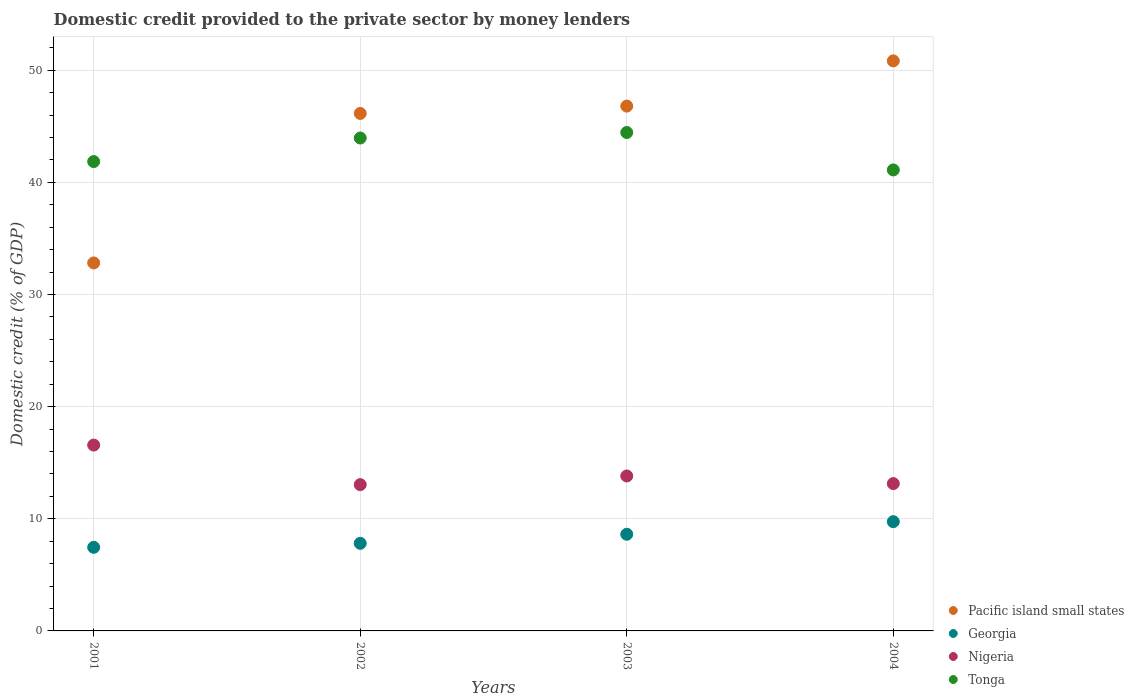What is the domestic credit provided to the private sector by money lenders in Nigeria in 2002?
Provide a succinct answer. 13.04. Across all years, what is the maximum domestic credit provided to the private sector by money lenders in Nigeria?
Offer a very short reply. 16.57. Across all years, what is the minimum domestic credit provided to the private sector by money lenders in Nigeria?
Ensure brevity in your answer.  13.04. In which year was the domestic credit provided to the private sector by money lenders in Tonga maximum?
Your answer should be very brief. 2003. In which year was the domestic credit provided to the private sector by money lenders in Georgia minimum?
Keep it short and to the point. 2001. What is the total domestic credit provided to the private sector by money lenders in Pacific island small states in the graph?
Ensure brevity in your answer.  176.58. What is the difference between the domestic credit provided to the private sector by money lenders in Nigeria in 2001 and that in 2002?
Your response must be concise. 3.53. What is the difference between the domestic credit provided to the private sector by money lenders in Tonga in 2002 and the domestic credit provided to the private sector by money lenders in Pacific island small states in 2003?
Offer a very short reply. -2.84. What is the average domestic credit provided to the private sector by money lenders in Georgia per year?
Offer a very short reply. 8.41. In the year 2004, what is the difference between the domestic credit provided to the private sector by money lenders in Nigeria and domestic credit provided to the private sector by money lenders in Tonga?
Your response must be concise. -27.97. In how many years, is the domestic credit provided to the private sector by money lenders in Tonga greater than 38 %?
Ensure brevity in your answer.  4. What is the ratio of the domestic credit provided to the private sector by money lenders in Pacific island small states in 2002 to that in 2004?
Ensure brevity in your answer.  0.91. Is the domestic credit provided to the private sector by money lenders in Pacific island small states in 2001 less than that in 2003?
Your answer should be compact. Yes. What is the difference between the highest and the second highest domestic credit provided to the private sector by money lenders in Georgia?
Give a very brief answer. 1.12. What is the difference between the highest and the lowest domestic credit provided to the private sector by money lenders in Tonga?
Your response must be concise. 3.34. In how many years, is the domestic credit provided to the private sector by money lenders in Pacific island small states greater than the average domestic credit provided to the private sector by money lenders in Pacific island small states taken over all years?
Offer a terse response. 3. Is the sum of the domestic credit provided to the private sector by money lenders in Pacific island small states in 2001 and 2004 greater than the maximum domestic credit provided to the private sector by money lenders in Nigeria across all years?
Ensure brevity in your answer.  Yes. Is it the case that in every year, the sum of the domestic credit provided to the private sector by money lenders in Nigeria and domestic credit provided to the private sector by money lenders in Tonga  is greater than the domestic credit provided to the private sector by money lenders in Pacific island small states?
Offer a very short reply. Yes. Does the domestic credit provided to the private sector by money lenders in Nigeria monotonically increase over the years?
Ensure brevity in your answer.  No. What is the difference between two consecutive major ticks on the Y-axis?
Your answer should be very brief. 10. Does the graph contain grids?
Your answer should be compact. Yes. How many legend labels are there?
Your response must be concise. 4. How are the legend labels stacked?
Your answer should be very brief. Vertical. What is the title of the graph?
Ensure brevity in your answer.  Domestic credit provided to the private sector by money lenders. Does "Venezuela" appear as one of the legend labels in the graph?
Offer a very short reply. No. What is the label or title of the X-axis?
Your answer should be very brief. Years. What is the label or title of the Y-axis?
Offer a terse response. Domestic credit (% of GDP). What is the Domestic credit (% of GDP) of Pacific island small states in 2001?
Give a very brief answer. 32.81. What is the Domestic credit (% of GDP) of Georgia in 2001?
Your answer should be compact. 7.45. What is the Domestic credit (% of GDP) of Nigeria in 2001?
Provide a succinct answer. 16.57. What is the Domestic credit (% of GDP) in Tonga in 2001?
Offer a very short reply. 41.85. What is the Domestic credit (% of GDP) of Pacific island small states in 2002?
Your response must be concise. 46.14. What is the Domestic credit (% of GDP) of Georgia in 2002?
Offer a very short reply. 7.81. What is the Domestic credit (% of GDP) in Nigeria in 2002?
Provide a succinct answer. 13.04. What is the Domestic credit (% of GDP) of Tonga in 2002?
Provide a succinct answer. 43.95. What is the Domestic credit (% of GDP) of Pacific island small states in 2003?
Offer a terse response. 46.8. What is the Domestic credit (% of GDP) of Georgia in 2003?
Your response must be concise. 8.62. What is the Domestic credit (% of GDP) in Nigeria in 2003?
Make the answer very short. 13.82. What is the Domestic credit (% of GDP) of Tonga in 2003?
Your answer should be compact. 44.44. What is the Domestic credit (% of GDP) of Pacific island small states in 2004?
Make the answer very short. 50.83. What is the Domestic credit (% of GDP) in Georgia in 2004?
Keep it short and to the point. 9.74. What is the Domestic credit (% of GDP) of Nigeria in 2004?
Offer a terse response. 13.14. What is the Domestic credit (% of GDP) in Tonga in 2004?
Your answer should be very brief. 41.11. Across all years, what is the maximum Domestic credit (% of GDP) in Pacific island small states?
Your response must be concise. 50.83. Across all years, what is the maximum Domestic credit (% of GDP) in Georgia?
Offer a terse response. 9.74. Across all years, what is the maximum Domestic credit (% of GDP) of Nigeria?
Ensure brevity in your answer.  16.57. Across all years, what is the maximum Domestic credit (% of GDP) of Tonga?
Keep it short and to the point. 44.44. Across all years, what is the minimum Domestic credit (% of GDP) in Pacific island small states?
Make the answer very short. 32.81. Across all years, what is the minimum Domestic credit (% of GDP) in Georgia?
Keep it short and to the point. 7.45. Across all years, what is the minimum Domestic credit (% of GDP) of Nigeria?
Your response must be concise. 13.04. Across all years, what is the minimum Domestic credit (% of GDP) in Tonga?
Your answer should be very brief. 41.11. What is the total Domestic credit (% of GDP) in Pacific island small states in the graph?
Offer a terse response. 176.58. What is the total Domestic credit (% of GDP) of Georgia in the graph?
Your answer should be very brief. 33.63. What is the total Domestic credit (% of GDP) of Nigeria in the graph?
Give a very brief answer. 56.57. What is the total Domestic credit (% of GDP) in Tonga in the graph?
Your answer should be compact. 171.35. What is the difference between the Domestic credit (% of GDP) in Pacific island small states in 2001 and that in 2002?
Keep it short and to the point. -13.33. What is the difference between the Domestic credit (% of GDP) of Georgia in 2001 and that in 2002?
Offer a terse response. -0.36. What is the difference between the Domestic credit (% of GDP) of Nigeria in 2001 and that in 2002?
Your response must be concise. 3.53. What is the difference between the Domestic credit (% of GDP) in Tonga in 2001 and that in 2002?
Ensure brevity in your answer.  -2.1. What is the difference between the Domestic credit (% of GDP) in Pacific island small states in 2001 and that in 2003?
Offer a very short reply. -13.98. What is the difference between the Domestic credit (% of GDP) in Georgia in 2001 and that in 2003?
Offer a terse response. -1.16. What is the difference between the Domestic credit (% of GDP) in Nigeria in 2001 and that in 2003?
Your answer should be very brief. 2.76. What is the difference between the Domestic credit (% of GDP) in Tonga in 2001 and that in 2003?
Your answer should be compact. -2.59. What is the difference between the Domestic credit (% of GDP) in Pacific island small states in 2001 and that in 2004?
Ensure brevity in your answer.  -18.01. What is the difference between the Domestic credit (% of GDP) in Georgia in 2001 and that in 2004?
Keep it short and to the point. -2.29. What is the difference between the Domestic credit (% of GDP) in Nigeria in 2001 and that in 2004?
Offer a terse response. 3.44. What is the difference between the Domestic credit (% of GDP) of Tonga in 2001 and that in 2004?
Ensure brevity in your answer.  0.74. What is the difference between the Domestic credit (% of GDP) in Pacific island small states in 2002 and that in 2003?
Offer a very short reply. -0.65. What is the difference between the Domestic credit (% of GDP) in Georgia in 2002 and that in 2003?
Your answer should be very brief. -0.81. What is the difference between the Domestic credit (% of GDP) in Nigeria in 2002 and that in 2003?
Provide a succinct answer. -0.77. What is the difference between the Domestic credit (% of GDP) in Tonga in 2002 and that in 2003?
Your answer should be compact. -0.49. What is the difference between the Domestic credit (% of GDP) of Pacific island small states in 2002 and that in 2004?
Your answer should be compact. -4.69. What is the difference between the Domestic credit (% of GDP) of Georgia in 2002 and that in 2004?
Your answer should be compact. -1.93. What is the difference between the Domestic credit (% of GDP) in Nigeria in 2002 and that in 2004?
Provide a short and direct response. -0.09. What is the difference between the Domestic credit (% of GDP) of Tonga in 2002 and that in 2004?
Offer a very short reply. 2.85. What is the difference between the Domestic credit (% of GDP) of Pacific island small states in 2003 and that in 2004?
Ensure brevity in your answer.  -4.03. What is the difference between the Domestic credit (% of GDP) of Georgia in 2003 and that in 2004?
Give a very brief answer. -1.12. What is the difference between the Domestic credit (% of GDP) of Nigeria in 2003 and that in 2004?
Keep it short and to the point. 0.68. What is the difference between the Domestic credit (% of GDP) of Tonga in 2003 and that in 2004?
Keep it short and to the point. 3.34. What is the difference between the Domestic credit (% of GDP) in Pacific island small states in 2001 and the Domestic credit (% of GDP) in Georgia in 2002?
Make the answer very short. 25. What is the difference between the Domestic credit (% of GDP) of Pacific island small states in 2001 and the Domestic credit (% of GDP) of Nigeria in 2002?
Offer a terse response. 19.77. What is the difference between the Domestic credit (% of GDP) of Pacific island small states in 2001 and the Domestic credit (% of GDP) of Tonga in 2002?
Offer a terse response. -11.14. What is the difference between the Domestic credit (% of GDP) of Georgia in 2001 and the Domestic credit (% of GDP) of Nigeria in 2002?
Offer a very short reply. -5.59. What is the difference between the Domestic credit (% of GDP) of Georgia in 2001 and the Domestic credit (% of GDP) of Tonga in 2002?
Your answer should be compact. -36.5. What is the difference between the Domestic credit (% of GDP) of Nigeria in 2001 and the Domestic credit (% of GDP) of Tonga in 2002?
Make the answer very short. -27.38. What is the difference between the Domestic credit (% of GDP) in Pacific island small states in 2001 and the Domestic credit (% of GDP) in Georgia in 2003?
Offer a terse response. 24.19. What is the difference between the Domestic credit (% of GDP) of Pacific island small states in 2001 and the Domestic credit (% of GDP) of Nigeria in 2003?
Your answer should be compact. 19. What is the difference between the Domestic credit (% of GDP) in Pacific island small states in 2001 and the Domestic credit (% of GDP) in Tonga in 2003?
Your answer should be very brief. -11.63. What is the difference between the Domestic credit (% of GDP) in Georgia in 2001 and the Domestic credit (% of GDP) in Nigeria in 2003?
Offer a terse response. -6.36. What is the difference between the Domestic credit (% of GDP) in Georgia in 2001 and the Domestic credit (% of GDP) in Tonga in 2003?
Provide a succinct answer. -36.99. What is the difference between the Domestic credit (% of GDP) in Nigeria in 2001 and the Domestic credit (% of GDP) in Tonga in 2003?
Your response must be concise. -27.87. What is the difference between the Domestic credit (% of GDP) in Pacific island small states in 2001 and the Domestic credit (% of GDP) in Georgia in 2004?
Provide a short and direct response. 23.07. What is the difference between the Domestic credit (% of GDP) of Pacific island small states in 2001 and the Domestic credit (% of GDP) of Nigeria in 2004?
Ensure brevity in your answer.  19.68. What is the difference between the Domestic credit (% of GDP) in Pacific island small states in 2001 and the Domestic credit (% of GDP) in Tonga in 2004?
Give a very brief answer. -8.29. What is the difference between the Domestic credit (% of GDP) of Georgia in 2001 and the Domestic credit (% of GDP) of Nigeria in 2004?
Give a very brief answer. -5.68. What is the difference between the Domestic credit (% of GDP) in Georgia in 2001 and the Domestic credit (% of GDP) in Tonga in 2004?
Provide a short and direct response. -33.65. What is the difference between the Domestic credit (% of GDP) of Nigeria in 2001 and the Domestic credit (% of GDP) of Tonga in 2004?
Offer a very short reply. -24.53. What is the difference between the Domestic credit (% of GDP) of Pacific island small states in 2002 and the Domestic credit (% of GDP) of Georgia in 2003?
Ensure brevity in your answer.  37.52. What is the difference between the Domestic credit (% of GDP) of Pacific island small states in 2002 and the Domestic credit (% of GDP) of Nigeria in 2003?
Your response must be concise. 32.33. What is the difference between the Domestic credit (% of GDP) in Pacific island small states in 2002 and the Domestic credit (% of GDP) in Tonga in 2003?
Provide a succinct answer. 1.7. What is the difference between the Domestic credit (% of GDP) of Georgia in 2002 and the Domestic credit (% of GDP) of Nigeria in 2003?
Give a very brief answer. -6.01. What is the difference between the Domestic credit (% of GDP) of Georgia in 2002 and the Domestic credit (% of GDP) of Tonga in 2003?
Offer a very short reply. -36.63. What is the difference between the Domestic credit (% of GDP) in Nigeria in 2002 and the Domestic credit (% of GDP) in Tonga in 2003?
Keep it short and to the point. -31.4. What is the difference between the Domestic credit (% of GDP) of Pacific island small states in 2002 and the Domestic credit (% of GDP) of Georgia in 2004?
Give a very brief answer. 36.4. What is the difference between the Domestic credit (% of GDP) of Pacific island small states in 2002 and the Domestic credit (% of GDP) of Nigeria in 2004?
Keep it short and to the point. 33.01. What is the difference between the Domestic credit (% of GDP) in Pacific island small states in 2002 and the Domestic credit (% of GDP) in Tonga in 2004?
Your answer should be compact. 5.04. What is the difference between the Domestic credit (% of GDP) of Georgia in 2002 and the Domestic credit (% of GDP) of Nigeria in 2004?
Make the answer very short. -5.33. What is the difference between the Domestic credit (% of GDP) of Georgia in 2002 and the Domestic credit (% of GDP) of Tonga in 2004?
Ensure brevity in your answer.  -33.3. What is the difference between the Domestic credit (% of GDP) in Nigeria in 2002 and the Domestic credit (% of GDP) in Tonga in 2004?
Offer a very short reply. -28.06. What is the difference between the Domestic credit (% of GDP) in Pacific island small states in 2003 and the Domestic credit (% of GDP) in Georgia in 2004?
Your response must be concise. 37.05. What is the difference between the Domestic credit (% of GDP) of Pacific island small states in 2003 and the Domestic credit (% of GDP) of Nigeria in 2004?
Provide a short and direct response. 33.66. What is the difference between the Domestic credit (% of GDP) in Pacific island small states in 2003 and the Domestic credit (% of GDP) in Tonga in 2004?
Offer a very short reply. 5.69. What is the difference between the Domestic credit (% of GDP) of Georgia in 2003 and the Domestic credit (% of GDP) of Nigeria in 2004?
Your response must be concise. -4.52. What is the difference between the Domestic credit (% of GDP) in Georgia in 2003 and the Domestic credit (% of GDP) in Tonga in 2004?
Make the answer very short. -32.49. What is the difference between the Domestic credit (% of GDP) of Nigeria in 2003 and the Domestic credit (% of GDP) of Tonga in 2004?
Your answer should be compact. -27.29. What is the average Domestic credit (% of GDP) in Pacific island small states per year?
Provide a short and direct response. 44.15. What is the average Domestic credit (% of GDP) in Georgia per year?
Ensure brevity in your answer.  8.41. What is the average Domestic credit (% of GDP) in Nigeria per year?
Keep it short and to the point. 14.14. What is the average Domestic credit (% of GDP) of Tonga per year?
Your answer should be very brief. 42.84. In the year 2001, what is the difference between the Domestic credit (% of GDP) in Pacific island small states and Domestic credit (% of GDP) in Georgia?
Offer a very short reply. 25.36. In the year 2001, what is the difference between the Domestic credit (% of GDP) in Pacific island small states and Domestic credit (% of GDP) in Nigeria?
Offer a terse response. 16.24. In the year 2001, what is the difference between the Domestic credit (% of GDP) of Pacific island small states and Domestic credit (% of GDP) of Tonga?
Provide a short and direct response. -9.04. In the year 2001, what is the difference between the Domestic credit (% of GDP) in Georgia and Domestic credit (% of GDP) in Nigeria?
Your answer should be very brief. -9.12. In the year 2001, what is the difference between the Domestic credit (% of GDP) in Georgia and Domestic credit (% of GDP) in Tonga?
Offer a terse response. -34.4. In the year 2001, what is the difference between the Domestic credit (% of GDP) of Nigeria and Domestic credit (% of GDP) of Tonga?
Your answer should be compact. -25.28. In the year 2002, what is the difference between the Domestic credit (% of GDP) of Pacific island small states and Domestic credit (% of GDP) of Georgia?
Your answer should be very brief. 38.33. In the year 2002, what is the difference between the Domestic credit (% of GDP) in Pacific island small states and Domestic credit (% of GDP) in Nigeria?
Offer a terse response. 33.1. In the year 2002, what is the difference between the Domestic credit (% of GDP) of Pacific island small states and Domestic credit (% of GDP) of Tonga?
Offer a terse response. 2.19. In the year 2002, what is the difference between the Domestic credit (% of GDP) of Georgia and Domestic credit (% of GDP) of Nigeria?
Your response must be concise. -5.23. In the year 2002, what is the difference between the Domestic credit (% of GDP) in Georgia and Domestic credit (% of GDP) in Tonga?
Offer a terse response. -36.14. In the year 2002, what is the difference between the Domestic credit (% of GDP) in Nigeria and Domestic credit (% of GDP) in Tonga?
Make the answer very short. -30.91. In the year 2003, what is the difference between the Domestic credit (% of GDP) in Pacific island small states and Domestic credit (% of GDP) in Georgia?
Keep it short and to the point. 38.18. In the year 2003, what is the difference between the Domestic credit (% of GDP) of Pacific island small states and Domestic credit (% of GDP) of Nigeria?
Offer a very short reply. 32.98. In the year 2003, what is the difference between the Domestic credit (% of GDP) of Pacific island small states and Domestic credit (% of GDP) of Tonga?
Keep it short and to the point. 2.35. In the year 2003, what is the difference between the Domestic credit (% of GDP) in Georgia and Domestic credit (% of GDP) in Nigeria?
Give a very brief answer. -5.2. In the year 2003, what is the difference between the Domestic credit (% of GDP) in Georgia and Domestic credit (% of GDP) in Tonga?
Keep it short and to the point. -35.82. In the year 2003, what is the difference between the Domestic credit (% of GDP) in Nigeria and Domestic credit (% of GDP) in Tonga?
Your answer should be very brief. -30.63. In the year 2004, what is the difference between the Domestic credit (% of GDP) in Pacific island small states and Domestic credit (% of GDP) in Georgia?
Offer a terse response. 41.09. In the year 2004, what is the difference between the Domestic credit (% of GDP) of Pacific island small states and Domestic credit (% of GDP) of Nigeria?
Your response must be concise. 37.69. In the year 2004, what is the difference between the Domestic credit (% of GDP) of Pacific island small states and Domestic credit (% of GDP) of Tonga?
Make the answer very short. 9.72. In the year 2004, what is the difference between the Domestic credit (% of GDP) in Georgia and Domestic credit (% of GDP) in Nigeria?
Give a very brief answer. -3.4. In the year 2004, what is the difference between the Domestic credit (% of GDP) in Georgia and Domestic credit (% of GDP) in Tonga?
Your answer should be very brief. -31.36. In the year 2004, what is the difference between the Domestic credit (% of GDP) of Nigeria and Domestic credit (% of GDP) of Tonga?
Keep it short and to the point. -27.97. What is the ratio of the Domestic credit (% of GDP) of Pacific island small states in 2001 to that in 2002?
Offer a terse response. 0.71. What is the ratio of the Domestic credit (% of GDP) of Georgia in 2001 to that in 2002?
Your answer should be compact. 0.95. What is the ratio of the Domestic credit (% of GDP) in Nigeria in 2001 to that in 2002?
Offer a very short reply. 1.27. What is the ratio of the Domestic credit (% of GDP) of Tonga in 2001 to that in 2002?
Provide a short and direct response. 0.95. What is the ratio of the Domestic credit (% of GDP) in Pacific island small states in 2001 to that in 2003?
Keep it short and to the point. 0.7. What is the ratio of the Domestic credit (% of GDP) of Georgia in 2001 to that in 2003?
Provide a short and direct response. 0.86. What is the ratio of the Domestic credit (% of GDP) in Nigeria in 2001 to that in 2003?
Your response must be concise. 1.2. What is the ratio of the Domestic credit (% of GDP) of Tonga in 2001 to that in 2003?
Provide a short and direct response. 0.94. What is the ratio of the Domestic credit (% of GDP) of Pacific island small states in 2001 to that in 2004?
Make the answer very short. 0.65. What is the ratio of the Domestic credit (% of GDP) in Georgia in 2001 to that in 2004?
Make the answer very short. 0.77. What is the ratio of the Domestic credit (% of GDP) of Nigeria in 2001 to that in 2004?
Provide a short and direct response. 1.26. What is the ratio of the Domestic credit (% of GDP) of Tonga in 2001 to that in 2004?
Keep it short and to the point. 1.02. What is the ratio of the Domestic credit (% of GDP) of Georgia in 2002 to that in 2003?
Offer a very short reply. 0.91. What is the ratio of the Domestic credit (% of GDP) in Nigeria in 2002 to that in 2003?
Offer a very short reply. 0.94. What is the ratio of the Domestic credit (% of GDP) of Pacific island small states in 2002 to that in 2004?
Your answer should be compact. 0.91. What is the ratio of the Domestic credit (% of GDP) of Georgia in 2002 to that in 2004?
Keep it short and to the point. 0.8. What is the ratio of the Domestic credit (% of GDP) of Nigeria in 2002 to that in 2004?
Provide a short and direct response. 0.99. What is the ratio of the Domestic credit (% of GDP) in Tonga in 2002 to that in 2004?
Ensure brevity in your answer.  1.07. What is the ratio of the Domestic credit (% of GDP) in Pacific island small states in 2003 to that in 2004?
Provide a succinct answer. 0.92. What is the ratio of the Domestic credit (% of GDP) of Georgia in 2003 to that in 2004?
Your response must be concise. 0.88. What is the ratio of the Domestic credit (% of GDP) in Nigeria in 2003 to that in 2004?
Offer a very short reply. 1.05. What is the ratio of the Domestic credit (% of GDP) in Tonga in 2003 to that in 2004?
Give a very brief answer. 1.08. What is the difference between the highest and the second highest Domestic credit (% of GDP) in Pacific island small states?
Offer a terse response. 4.03. What is the difference between the highest and the second highest Domestic credit (% of GDP) of Georgia?
Keep it short and to the point. 1.12. What is the difference between the highest and the second highest Domestic credit (% of GDP) in Nigeria?
Provide a short and direct response. 2.76. What is the difference between the highest and the second highest Domestic credit (% of GDP) in Tonga?
Your answer should be compact. 0.49. What is the difference between the highest and the lowest Domestic credit (% of GDP) of Pacific island small states?
Provide a short and direct response. 18.01. What is the difference between the highest and the lowest Domestic credit (% of GDP) of Georgia?
Give a very brief answer. 2.29. What is the difference between the highest and the lowest Domestic credit (% of GDP) in Nigeria?
Your response must be concise. 3.53. What is the difference between the highest and the lowest Domestic credit (% of GDP) in Tonga?
Your answer should be compact. 3.34. 